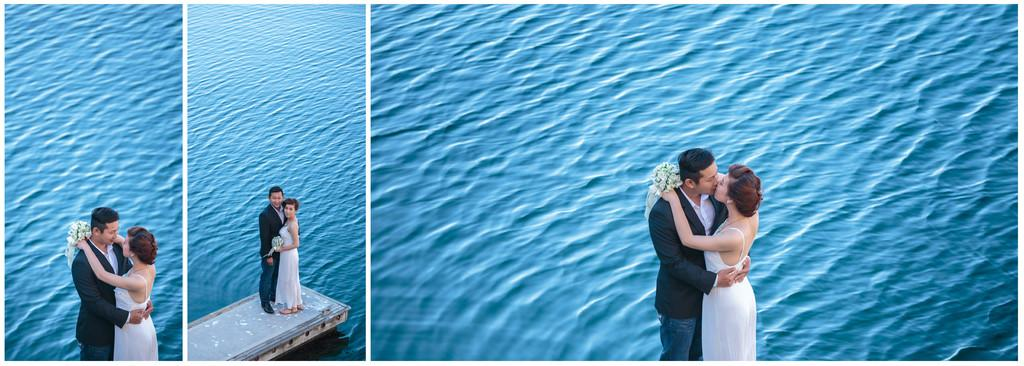How many people are in the image? There are six people in the image, as there are three couples. What are the couples doing in the image? The couples are standing on the edge of a bridge. What can be seen in the background of the image? There is water visible in the background of the image. What type of horses can be seen running in the background of the image? There are no horses present in the image; it features three couples standing on the edge of a bridge with water visible in the background. 